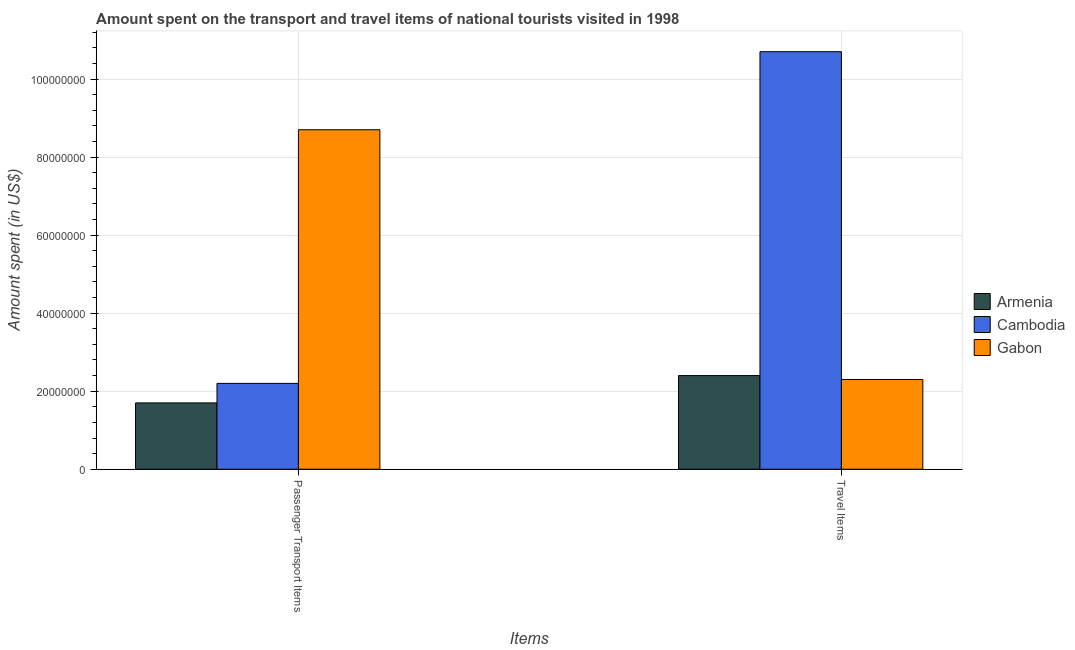How many groups of bars are there?
Give a very brief answer. 2. What is the label of the 1st group of bars from the left?
Provide a short and direct response. Passenger Transport Items. What is the amount spent in travel items in Cambodia?
Provide a succinct answer. 1.07e+08. Across all countries, what is the maximum amount spent in travel items?
Provide a short and direct response. 1.07e+08. Across all countries, what is the minimum amount spent in travel items?
Offer a terse response. 2.30e+07. In which country was the amount spent on passenger transport items maximum?
Give a very brief answer. Gabon. In which country was the amount spent in travel items minimum?
Offer a terse response. Gabon. What is the total amount spent in travel items in the graph?
Keep it short and to the point. 1.54e+08. What is the difference between the amount spent on passenger transport items in Gabon and that in Cambodia?
Provide a succinct answer. 6.50e+07. What is the difference between the amount spent in travel items in Gabon and the amount spent on passenger transport items in Armenia?
Provide a short and direct response. 6.00e+06. What is the average amount spent in travel items per country?
Provide a short and direct response. 5.13e+07. What is the difference between the amount spent in travel items and amount spent on passenger transport items in Armenia?
Provide a short and direct response. 7.00e+06. What is the ratio of the amount spent in travel items in Cambodia to that in Gabon?
Offer a terse response. 4.65. Is the amount spent in travel items in Armenia less than that in Gabon?
Your response must be concise. No. In how many countries, is the amount spent on passenger transport items greater than the average amount spent on passenger transport items taken over all countries?
Your answer should be very brief. 1. What does the 2nd bar from the left in Travel Items represents?
Your response must be concise. Cambodia. What does the 1st bar from the right in Travel Items represents?
Offer a terse response. Gabon. Are all the bars in the graph horizontal?
Your answer should be compact. No. What is the difference between two consecutive major ticks on the Y-axis?
Your answer should be very brief. 2.00e+07. Does the graph contain any zero values?
Ensure brevity in your answer.  No. Does the graph contain grids?
Your answer should be compact. Yes. How are the legend labels stacked?
Your response must be concise. Vertical. What is the title of the graph?
Your answer should be compact. Amount spent on the transport and travel items of national tourists visited in 1998. What is the label or title of the X-axis?
Offer a very short reply. Items. What is the label or title of the Y-axis?
Ensure brevity in your answer.  Amount spent (in US$). What is the Amount spent (in US$) of Armenia in Passenger Transport Items?
Your response must be concise. 1.70e+07. What is the Amount spent (in US$) in Cambodia in Passenger Transport Items?
Give a very brief answer. 2.20e+07. What is the Amount spent (in US$) in Gabon in Passenger Transport Items?
Make the answer very short. 8.70e+07. What is the Amount spent (in US$) of Armenia in Travel Items?
Your answer should be compact. 2.40e+07. What is the Amount spent (in US$) in Cambodia in Travel Items?
Offer a terse response. 1.07e+08. What is the Amount spent (in US$) in Gabon in Travel Items?
Your response must be concise. 2.30e+07. Across all Items, what is the maximum Amount spent (in US$) of Armenia?
Provide a succinct answer. 2.40e+07. Across all Items, what is the maximum Amount spent (in US$) of Cambodia?
Keep it short and to the point. 1.07e+08. Across all Items, what is the maximum Amount spent (in US$) in Gabon?
Your answer should be very brief. 8.70e+07. Across all Items, what is the minimum Amount spent (in US$) in Armenia?
Keep it short and to the point. 1.70e+07. Across all Items, what is the minimum Amount spent (in US$) of Cambodia?
Offer a very short reply. 2.20e+07. Across all Items, what is the minimum Amount spent (in US$) in Gabon?
Give a very brief answer. 2.30e+07. What is the total Amount spent (in US$) in Armenia in the graph?
Offer a very short reply. 4.10e+07. What is the total Amount spent (in US$) in Cambodia in the graph?
Your answer should be very brief. 1.29e+08. What is the total Amount spent (in US$) of Gabon in the graph?
Your answer should be compact. 1.10e+08. What is the difference between the Amount spent (in US$) of Armenia in Passenger Transport Items and that in Travel Items?
Your response must be concise. -7.00e+06. What is the difference between the Amount spent (in US$) of Cambodia in Passenger Transport Items and that in Travel Items?
Make the answer very short. -8.50e+07. What is the difference between the Amount spent (in US$) of Gabon in Passenger Transport Items and that in Travel Items?
Give a very brief answer. 6.40e+07. What is the difference between the Amount spent (in US$) in Armenia in Passenger Transport Items and the Amount spent (in US$) in Cambodia in Travel Items?
Your answer should be compact. -9.00e+07. What is the difference between the Amount spent (in US$) of Armenia in Passenger Transport Items and the Amount spent (in US$) of Gabon in Travel Items?
Keep it short and to the point. -6.00e+06. What is the average Amount spent (in US$) of Armenia per Items?
Your answer should be compact. 2.05e+07. What is the average Amount spent (in US$) of Cambodia per Items?
Your answer should be very brief. 6.45e+07. What is the average Amount spent (in US$) in Gabon per Items?
Your response must be concise. 5.50e+07. What is the difference between the Amount spent (in US$) in Armenia and Amount spent (in US$) in Cambodia in Passenger Transport Items?
Provide a short and direct response. -5.00e+06. What is the difference between the Amount spent (in US$) in Armenia and Amount spent (in US$) in Gabon in Passenger Transport Items?
Provide a succinct answer. -7.00e+07. What is the difference between the Amount spent (in US$) of Cambodia and Amount spent (in US$) of Gabon in Passenger Transport Items?
Provide a short and direct response. -6.50e+07. What is the difference between the Amount spent (in US$) in Armenia and Amount spent (in US$) in Cambodia in Travel Items?
Your answer should be compact. -8.30e+07. What is the difference between the Amount spent (in US$) in Cambodia and Amount spent (in US$) in Gabon in Travel Items?
Offer a terse response. 8.40e+07. What is the ratio of the Amount spent (in US$) of Armenia in Passenger Transport Items to that in Travel Items?
Provide a succinct answer. 0.71. What is the ratio of the Amount spent (in US$) in Cambodia in Passenger Transport Items to that in Travel Items?
Make the answer very short. 0.21. What is the ratio of the Amount spent (in US$) in Gabon in Passenger Transport Items to that in Travel Items?
Keep it short and to the point. 3.78. What is the difference between the highest and the second highest Amount spent (in US$) of Cambodia?
Keep it short and to the point. 8.50e+07. What is the difference between the highest and the second highest Amount spent (in US$) of Gabon?
Your answer should be compact. 6.40e+07. What is the difference between the highest and the lowest Amount spent (in US$) in Armenia?
Provide a short and direct response. 7.00e+06. What is the difference between the highest and the lowest Amount spent (in US$) of Cambodia?
Keep it short and to the point. 8.50e+07. What is the difference between the highest and the lowest Amount spent (in US$) in Gabon?
Your response must be concise. 6.40e+07. 